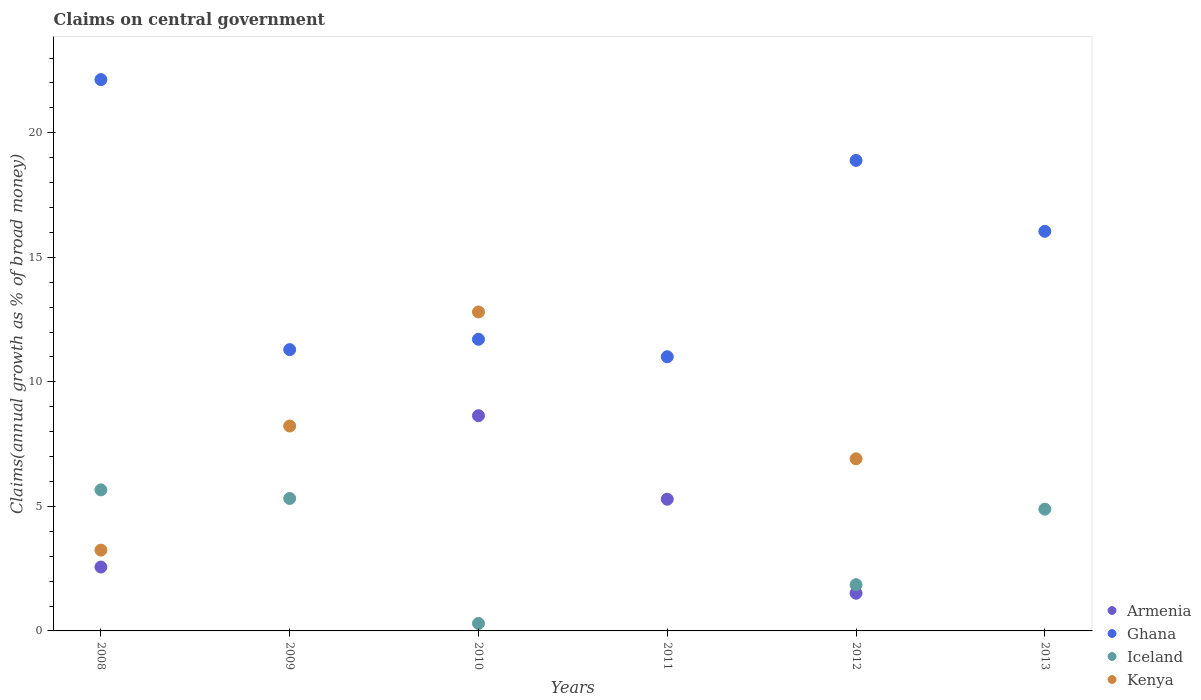Is the number of dotlines equal to the number of legend labels?
Keep it short and to the point. No. What is the percentage of broad money claimed on centeral government in Armenia in 2011?
Your answer should be compact. 5.29. Across all years, what is the maximum percentage of broad money claimed on centeral government in Armenia?
Your answer should be very brief. 8.64. What is the total percentage of broad money claimed on centeral government in Kenya in the graph?
Your response must be concise. 31.19. What is the difference between the percentage of broad money claimed on centeral government in Iceland in 2009 and that in 2013?
Offer a very short reply. 0.43. What is the difference between the percentage of broad money claimed on centeral government in Iceland in 2013 and the percentage of broad money claimed on centeral government in Ghana in 2009?
Your response must be concise. -6.41. What is the average percentage of broad money claimed on centeral government in Ghana per year?
Provide a succinct answer. 15.18. In the year 2012, what is the difference between the percentage of broad money claimed on centeral government in Ghana and percentage of broad money claimed on centeral government in Armenia?
Make the answer very short. 17.38. In how many years, is the percentage of broad money claimed on centeral government in Armenia greater than 2 %?
Provide a short and direct response. 3. What is the ratio of the percentage of broad money claimed on centeral government in Ghana in 2009 to that in 2013?
Provide a short and direct response. 0.7. Is the percentage of broad money claimed on centeral government in Ghana in 2009 less than that in 2011?
Provide a succinct answer. No. What is the difference between the highest and the second highest percentage of broad money claimed on centeral government in Ghana?
Offer a very short reply. 3.24. What is the difference between the highest and the lowest percentage of broad money claimed on centeral government in Iceland?
Your answer should be very brief. 5.66. Is the sum of the percentage of broad money claimed on centeral government in Iceland in 2008 and 2012 greater than the maximum percentage of broad money claimed on centeral government in Ghana across all years?
Provide a short and direct response. No. Is it the case that in every year, the sum of the percentage of broad money claimed on centeral government in Iceland and percentage of broad money claimed on centeral government in Kenya  is greater than the percentage of broad money claimed on centeral government in Armenia?
Ensure brevity in your answer.  No. Is the percentage of broad money claimed on centeral government in Armenia strictly greater than the percentage of broad money claimed on centeral government in Iceland over the years?
Offer a terse response. No. Are the values on the major ticks of Y-axis written in scientific E-notation?
Ensure brevity in your answer.  No. Does the graph contain grids?
Keep it short and to the point. No. How many legend labels are there?
Give a very brief answer. 4. How are the legend labels stacked?
Your answer should be compact. Vertical. What is the title of the graph?
Give a very brief answer. Claims on central government. Does "Luxembourg" appear as one of the legend labels in the graph?
Your answer should be compact. No. What is the label or title of the Y-axis?
Keep it short and to the point. Claims(annual growth as % of broad money). What is the Claims(annual growth as % of broad money) of Armenia in 2008?
Give a very brief answer. 2.57. What is the Claims(annual growth as % of broad money) in Ghana in 2008?
Keep it short and to the point. 22.13. What is the Claims(annual growth as % of broad money) of Iceland in 2008?
Offer a very short reply. 5.66. What is the Claims(annual growth as % of broad money) in Kenya in 2008?
Your answer should be compact. 3.24. What is the Claims(annual growth as % of broad money) of Ghana in 2009?
Offer a very short reply. 11.29. What is the Claims(annual growth as % of broad money) in Iceland in 2009?
Your answer should be very brief. 5.32. What is the Claims(annual growth as % of broad money) in Kenya in 2009?
Give a very brief answer. 8.23. What is the Claims(annual growth as % of broad money) in Armenia in 2010?
Your response must be concise. 8.64. What is the Claims(annual growth as % of broad money) in Ghana in 2010?
Provide a short and direct response. 11.71. What is the Claims(annual growth as % of broad money) of Iceland in 2010?
Give a very brief answer. 0.3. What is the Claims(annual growth as % of broad money) of Kenya in 2010?
Provide a succinct answer. 12.81. What is the Claims(annual growth as % of broad money) of Armenia in 2011?
Give a very brief answer. 5.29. What is the Claims(annual growth as % of broad money) in Ghana in 2011?
Provide a succinct answer. 11.01. What is the Claims(annual growth as % of broad money) of Kenya in 2011?
Your answer should be compact. 0. What is the Claims(annual growth as % of broad money) of Armenia in 2012?
Provide a succinct answer. 1.51. What is the Claims(annual growth as % of broad money) in Ghana in 2012?
Give a very brief answer. 18.89. What is the Claims(annual growth as % of broad money) of Iceland in 2012?
Give a very brief answer. 1.86. What is the Claims(annual growth as % of broad money) of Kenya in 2012?
Ensure brevity in your answer.  6.91. What is the Claims(annual growth as % of broad money) of Ghana in 2013?
Offer a very short reply. 16.04. What is the Claims(annual growth as % of broad money) in Iceland in 2013?
Ensure brevity in your answer.  4.89. What is the Claims(annual growth as % of broad money) of Kenya in 2013?
Your answer should be very brief. 0. Across all years, what is the maximum Claims(annual growth as % of broad money) of Armenia?
Offer a terse response. 8.64. Across all years, what is the maximum Claims(annual growth as % of broad money) in Ghana?
Ensure brevity in your answer.  22.13. Across all years, what is the maximum Claims(annual growth as % of broad money) of Iceland?
Give a very brief answer. 5.66. Across all years, what is the maximum Claims(annual growth as % of broad money) of Kenya?
Ensure brevity in your answer.  12.81. Across all years, what is the minimum Claims(annual growth as % of broad money) in Armenia?
Your answer should be compact. 0. Across all years, what is the minimum Claims(annual growth as % of broad money) in Ghana?
Give a very brief answer. 11.01. Across all years, what is the minimum Claims(annual growth as % of broad money) of Iceland?
Ensure brevity in your answer.  0. Across all years, what is the minimum Claims(annual growth as % of broad money) of Kenya?
Your answer should be very brief. 0. What is the total Claims(annual growth as % of broad money) in Armenia in the graph?
Provide a succinct answer. 18.01. What is the total Claims(annual growth as % of broad money) in Ghana in the graph?
Provide a succinct answer. 91.08. What is the total Claims(annual growth as % of broad money) of Iceland in the graph?
Your answer should be very brief. 18.03. What is the total Claims(annual growth as % of broad money) in Kenya in the graph?
Ensure brevity in your answer.  31.19. What is the difference between the Claims(annual growth as % of broad money) of Ghana in 2008 and that in 2009?
Make the answer very short. 10.84. What is the difference between the Claims(annual growth as % of broad money) of Iceland in 2008 and that in 2009?
Give a very brief answer. 0.35. What is the difference between the Claims(annual growth as % of broad money) of Kenya in 2008 and that in 2009?
Offer a very short reply. -4.98. What is the difference between the Claims(annual growth as % of broad money) of Armenia in 2008 and that in 2010?
Your answer should be compact. -6.08. What is the difference between the Claims(annual growth as % of broad money) of Ghana in 2008 and that in 2010?
Your response must be concise. 10.43. What is the difference between the Claims(annual growth as % of broad money) in Iceland in 2008 and that in 2010?
Give a very brief answer. 5.36. What is the difference between the Claims(annual growth as % of broad money) of Kenya in 2008 and that in 2010?
Make the answer very short. -9.56. What is the difference between the Claims(annual growth as % of broad money) in Armenia in 2008 and that in 2011?
Offer a terse response. -2.72. What is the difference between the Claims(annual growth as % of broad money) of Ghana in 2008 and that in 2011?
Your answer should be very brief. 11.13. What is the difference between the Claims(annual growth as % of broad money) of Armenia in 2008 and that in 2012?
Offer a terse response. 1.05. What is the difference between the Claims(annual growth as % of broad money) in Ghana in 2008 and that in 2012?
Give a very brief answer. 3.24. What is the difference between the Claims(annual growth as % of broad money) in Iceland in 2008 and that in 2012?
Your answer should be very brief. 3.81. What is the difference between the Claims(annual growth as % of broad money) of Kenya in 2008 and that in 2012?
Provide a succinct answer. -3.67. What is the difference between the Claims(annual growth as % of broad money) of Ghana in 2008 and that in 2013?
Give a very brief answer. 6.09. What is the difference between the Claims(annual growth as % of broad money) in Iceland in 2008 and that in 2013?
Keep it short and to the point. 0.77. What is the difference between the Claims(annual growth as % of broad money) in Ghana in 2009 and that in 2010?
Give a very brief answer. -0.41. What is the difference between the Claims(annual growth as % of broad money) in Iceland in 2009 and that in 2010?
Provide a short and direct response. 5.02. What is the difference between the Claims(annual growth as % of broad money) in Kenya in 2009 and that in 2010?
Ensure brevity in your answer.  -4.58. What is the difference between the Claims(annual growth as % of broad money) of Ghana in 2009 and that in 2011?
Provide a short and direct response. 0.29. What is the difference between the Claims(annual growth as % of broad money) of Ghana in 2009 and that in 2012?
Give a very brief answer. -7.6. What is the difference between the Claims(annual growth as % of broad money) in Iceland in 2009 and that in 2012?
Offer a terse response. 3.46. What is the difference between the Claims(annual growth as % of broad money) in Kenya in 2009 and that in 2012?
Offer a terse response. 1.32. What is the difference between the Claims(annual growth as % of broad money) in Ghana in 2009 and that in 2013?
Offer a very short reply. -4.75. What is the difference between the Claims(annual growth as % of broad money) in Iceland in 2009 and that in 2013?
Your answer should be very brief. 0.43. What is the difference between the Claims(annual growth as % of broad money) in Armenia in 2010 and that in 2011?
Give a very brief answer. 3.35. What is the difference between the Claims(annual growth as % of broad money) of Ghana in 2010 and that in 2011?
Provide a succinct answer. 0.7. What is the difference between the Claims(annual growth as % of broad money) in Armenia in 2010 and that in 2012?
Give a very brief answer. 7.13. What is the difference between the Claims(annual growth as % of broad money) of Ghana in 2010 and that in 2012?
Provide a short and direct response. -7.18. What is the difference between the Claims(annual growth as % of broad money) in Iceland in 2010 and that in 2012?
Give a very brief answer. -1.56. What is the difference between the Claims(annual growth as % of broad money) of Kenya in 2010 and that in 2012?
Keep it short and to the point. 5.9. What is the difference between the Claims(annual growth as % of broad money) in Ghana in 2010 and that in 2013?
Your answer should be compact. -4.33. What is the difference between the Claims(annual growth as % of broad money) in Iceland in 2010 and that in 2013?
Your answer should be compact. -4.59. What is the difference between the Claims(annual growth as % of broad money) of Armenia in 2011 and that in 2012?
Your answer should be very brief. 3.78. What is the difference between the Claims(annual growth as % of broad money) in Ghana in 2011 and that in 2012?
Your answer should be very brief. -7.88. What is the difference between the Claims(annual growth as % of broad money) in Ghana in 2011 and that in 2013?
Make the answer very short. -5.03. What is the difference between the Claims(annual growth as % of broad money) in Ghana in 2012 and that in 2013?
Offer a terse response. 2.85. What is the difference between the Claims(annual growth as % of broad money) of Iceland in 2012 and that in 2013?
Give a very brief answer. -3.03. What is the difference between the Claims(annual growth as % of broad money) of Armenia in 2008 and the Claims(annual growth as % of broad money) of Ghana in 2009?
Your answer should be very brief. -8.73. What is the difference between the Claims(annual growth as % of broad money) of Armenia in 2008 and the Claims(annual growth as % of broad money) of Iceland in 2009?
Ensure brevity in your answer.  -2.75. What is the difference between the Claims(annual growth as % of broad money) of Armenia in 2008 and the Claims(annual growth as % of broad money) of Kenya in 2009?
Give a very brief answer. -5.66. What is the difference between the Claims(annual growth as % of broad money) in Ghana in 2008 and the Claims(annual growth as % of broad money) in Iceland in 2009?
Offer a very short reply. 16.82. What is the difference between the Claims(annual growth as % of broad money) in Ghana in 2008 and the Claims(annual growth as % of broad money) in Kenya in 2009?
Keep it short and to the point. 13.91. What is the difference between the Claims(annual growth as % of broad money) of Iceland in 2008 and the Claims(annual growth as % of broad money) of Kenya in 2009?
Ensure brevity in your answer.  -2.56. What is the difference between the Claims(annual growth as % of broad money) of Armenia in 2008 and the Claims(annual growth as % of broad money) of Ghana in 2010?
Ensure brevity in your answer.  -9.14. What is the difference between the Claims(annual growth as % of broad money) in Armenia in 2008 and the Claims(annual growth as % of broad money) in Iceland in 2010?
Offer a terse response. 2.26. What is the difference between the Claims(annual growth as % of broad money) of Armenia in 2008 and the Claims(annual growth as % of broad money) of Kenya in 2010?
Your answer should be compact. -10.24. What is the difference between the Claims(annual growth as % of broad money) in Ghana in 2008 and the Claims(annual growth as % of broad money) in Iceland in 2010?
Ensure brevity in your answer.  21.83. What is the difference between the Claims(annual growth as % of broad money) of Ghana in 2008 and the Claims(annual growth as % of broad money) of Kenya in 2010?
Offer a terse response. 9.33. What is the difference between the Claims(annual growth as % of broad money) in Iceland in 2008 and the Claims(annual growth as % of broad money) in Kenya in 2010?
Your response must be concise. -7.14. What is the difference between the Claims(annual growth as % of broad money) of Armenia in 2008 and the Claims(annual growth as % of broad money) of Ghana in 2011?
Provide a succinct answer. -8.44. What is the difference between the Claims(annual growth as % of broad money) of Armenia in 2008 and the Claims(annual growth as % of broad money) of Ghana in 2012?
Make the answer very short. -16.32. What is the difference between the Claims(annual growth as % of broad money) of Armenia in 2008 and the Claims(annual growth as % of broad money) of Iceland in 2012?
Offer a very short reply. 0.71. What is the difference between the Claims(annual growth as % of broad money) of Armenia in 2008 and the Claims(annual growth as % of broad money) of Kenya in 2012?
Give a very brief answer. -4.35. What is the difference between the Claims(annual growth as % of broad money) of Ghana in 2008 and the Claims(annual growth as % of broad money) of Iceland in 2012?
Your answer should be very brief. 20.28. What is the difference between the Claims(annual growth as % of broad money) in Ghana in 2008 and the Claims(annual growth as % of broad money) in Kenya in 2012?
Keep it short and to the point. 15.22. What is the difference between the Claims(annual growth as % of broad money) in Iceland in 2008 and the Claims(annual growth as % of broad money) in Kenya in 2012?
Give a very brief answer. -1.25. What is the difference between the Claims(annual growth as % of broad money) of Armenia in 2008 and the Claims(annual growth as % of broad money) of Ghana in 2013?
Your answer should be compact. -13.48. What is the difference between the Claims(annual growth as % of broad money) in Armenia in 2008 and the Claims(annual growth as % of broad money) in Iceland in 2013?
Ensure brevity in your answer.  -2.32. What is the difference between the Claims(annual growth as % of broad money) of Ghana in 2008 and the Claims(annual growth as % of broad money) of Iceland in 2013?
Give a very brief answer. 17.25. What is the difference between the Claims(annual growth as % of broad money) in Ghana in 2009 and the Claims(annual growth as % of broad money) in Iceland in 2010?
Ensure brevity in your answer.  10.99. What is the difference between the Claims(annual growth as % of broad money) of Ghana in 2009 and the Claims(annual growth as % of broad money) of Kenya in 2010?
Keep it short and to the point. -1.51. What is the difference between the Claims(annual growth as % of broad money) of Iceland in 2009 and the Claims(annual growth as % of broad money) of Kenya in 2010?
Offer a very short reply. -7.49. What is the difference between the Claims(annual growth as % of broad money) of Ghana in 2009 and the Claims(annual growth as % of broad money) of Iceland in 2012?
Give a very brief answer. 9.44. What is the difference between the Claims(annual growth as % of broad money) in Ghana in 2009 and the Claims(annual growth as % of broad money) in Kenya in 2012?
Your response must be concise. 4.38. What is the difference between the Claims(annual growth as % of broad money) of Iceland in 2009 and the Claims(annual growth as % of broad money) of Kenya in 2012?
Your answer should be compact. -1.59. What is the difference between the Claims(annual growth as % of broad money) of Ghana in 2009 and the Claims(annual growth as % of broad money) of Iceland in 2013?
Your response must be concise. 6.41. What is the difference between the Claims(annual growth as % of broad money) of Armenia in 2010 and the Claims(annual growth as % of broad money) of Ghana in 2011?
Provide a succinct answer. -2.37. What is the difference between the Claims(annual growth as % of broad money) of Armenia in 2010 and the Claims(annual growth as % of broad money) of Ghana in 2012?
Provide a succinct answer. -10.25. What is the difference between the Claims(annual growth as % of broad money) of Armenia in 2010 and the Claims(annual growth as % of broad money) of Iceland in 2012?
Provide a succinct answer. 6.79. What is the difference between the Claims(annual growth as % of broad money) of Armenia in 2010 and the Claims(annual growth as % of broad money) of Kenya in 2012?
Provide a succinct answer. 1.73. What is the difference between the Claims(annual growth as % of broad money) in Ghana in 2010 and the Claims(annual growth as % of broad money) in Iceland in 2012?
Your answer should be very brief. 9.85. What is the difference between the Claims(annual growth as % of broad money) of Ghana in 2010 and the Claims(annual growth as % of broad money) of Kenya in 2012?
Make the answer very short. 4.8. What is the difference between the Claims(annual growth as % of broad money) in Iceland in 2010 and the Claims(annual growth as % of broad money) in Kenya in 2012?
Provide a short and direct response. -6.61. What is the difference between the Claims(annual growth as % of broad money) of Armenia in 2010 and the Claims(annual growth as % of broad money) of Ghana in 2013?
Offer a very short reply. -7.4. What is the difference between the Claims(annual growth as % of broad money) of Armenia in 2010 and the Claims(annual growth as % of broad money) of Iceland in 2013?
Ensure brevity in your answer.  3.75. What is the difference between the Claims(annual growth as % of broad money) in Ghana in 2010 and the Claims(annual growth as % of broad money) in Iceland in 2013?
Give a very brief answer. 6.82. What is the difference between the Claims(annual growth as % of broad money) in Armenia in 2011 and the Claims(annual growth as % of broad money) in Ghana in 2012?
Provide a succinct answer. -13.6. What is the difference between the Claims(annual growth as % of broad money) of Armenia in 2011 and the Claims(annual growth as % of broad money) of Iceland in 2012?
Your answer should be compact. 3.43. What is the difference between the Claims(annual growth as % of broad money) of Armenia in 2011 and the Claims(annual growth as % of broad money) of Kenya in 2012?
Your response must be concise. -1.62. What is the difference between the Claims(annual growth as % of broad money) of Ghana in 2011 and the Claims(annual growth as % of broad money) of Iceland in 2012?
Ensure brevity in your answer.  9.15. What is the difference between the Claims(annual growth as % of broad money) in Ghana in 2011 and the Claims(annual growth as % of broad money) in Kenya in 2012?
Your answer should be compact. 4.1. What is the difference between the Claims(annual growth as % of broad money) of Armenia in 2011 and the Claims(annual growth as % of broad money) of Ghana in 2013?
Provide a succinct answer. -10.76. What is the difference between the Claims(annual growth as % of broad money) in Armenia in 2011 and the Claims(annual growth as % of broad money) in Iceland in 2013?
Give a very brief answer. 0.4. What is the difference between the Claims(annual growth as % of broad money) in Ghana in 2011 and the Claims(annual growth as % of broad money) in Iceland in 2013?
Give a very brief answer. 6.12. What is the difference between the Claims(annual growth as % of broad money) in Armenia in 2012 and the Claims(annual growth as % of broad money) in Ghana in 2013?
Your response must be concise. -14.53. What is the difference between the Claims(annual growth as % of broad money) in Armenia in 2012 and the Claims(annual growth as % of broad money) in Iceland in 2013?
Provide a short and direct response. -3.38. What is the difference between the Claims(annual growth as % of broad money) of Ghana in 2012 and the Claims(annual growth as % of broad money) of Iceland in 2013?
Give a very brief answer. 14. What is the average Claims(annual growth as % of broad money) of Armenia per year?
Your response must be concise. 3. What is the average Claims(annual growth as % of broad money) in Ghana per year?
Keep it short and to the point. 15.18. What is the average Claims(annual growth as % of broad money) of Iceland per year?
Provide a succinct answer. 3. What is the average Claims(annual growth as % of broad money) of Kenya per year?
Your answer should be very brief. 5.2. In the year 2008, what is the difference between the Claims(annual growth as % of broad money) of Armenia and Claims(annual growth as % of broad money) of Ghana?
Offer a very short reply. -19.57. In the year 2008, what is the difference between the Claims(annual growth as % of broad money) in Armenia and Claims(annual growth as % of broad money) in Iceland?
Provide a succinct answer. -3.1. In the year 2008, what is the difference between the Claims(annual growth as % of broad money) of Armenia and Claims(annual growth as % of broad money) of Kenya?
Your response must be concise. -0.68. In the year 2008, what is the difference between the Claims(annual growth as % of broad money) in Ghana and Claims(annual growth as % of broad money) in Iceland?
Your response must be concise. 16.47. In the year 2008, what is the difference between the Claims(annual growth as % of broad money) of Ghana and Claims(annual growth as % of broad money) of Kenya?
Offer a terse response. 18.89. In the year 2008, what is the difference between the Claims(annual growth as % of broad money) of Iceland and Claims(annual growth as % of broad money) of Kenya?
Your response must be concise. 2.42. In the year 2009, what is the difference between the Claims(annual growth as % of broad money) of Ghana and Claims(annual growth as % of broad money) of Iceland?
Make the answer very short. 5.98. In the year 2009, what is the difference between the Claims(annual growth as % of broad money) in Ghana and Claims(annual growth as % of broad money) in Kenya?
Your answer should be compact. 3.07. In the year 2009, what is the difference between the Claims(annual growth as % of broad money) of Iceland and Claims(annual growth as % of broad money) of Kenya?
Your answer should be compact. -2.91. In the year 2010, what is the difference between the Claims(annual growth as % of broad money) in Armenia and Claims(annual growth as % of broad money) in Ghana?
Your answer should be very brief. -3.07. In the year 2010, what is the difference between the Claims(annual growth as % of broad money) in Armenia and Claims(annual growth as % of broad money) in Iceland?
Keep it short and to the point. 8.34. In the year 2010, what is the difference between the Claims(annual growth as % of broad money) of Armenia and Claims(annual growth as % of broad money) of Kenya?
Offer a terse response. -4.16. In the year 2010, what is the difference between the Claims(annual growth as % of broad money) of Ghana and Claims(annual growth as % of broad money) of Iceland?
Ensure brevity in your answer.  11.41. In the year 2010, what is the difference between the Claims(annual growth as % of broad money) of Ghana and Claims(annual growth as % of broad money) of Kenya?
Ensure brevity in your answer.  -1.1. In the year 2010, what is the difference between the Claims(annual growth as % of broad money) in Iceland and Claims(annual growth as % of broad money) in Kenya?
Make the answer very short. -12.51. In the year 2011, what is the difference between the Claims(annual growth as % of broad money) in Armenia and Claims(annual growth as % of broad money) in Ghana?
Give a very brief answer. -5.72. In the year 2012, what is the difference between the Claims(annual growth as % of broad money) of Armenia and Claims(annual growth as % of broad money) of Ghana?
Provide a succinct answer. -17.38. In the year 2012, what is the difference between the Claims(annual growth as % of broad money) of Armenia and Claims(annual growth as % of broad money) of Iceland?
Keep it short and to the point. -0.34. In the year 2012, what is the difference between the Claims(annual growth as % of broad money) of Armenia and Claims(annual growth as % of broad money) of Kenya?
Your answer should be compact. -5.4. In the year 2012, what is the difference between the Claims(annual growth as % of broad money) of Ghana and Claims(annual growth as % of broad money) of Iceland?
Ensure brevity in your answer.  17.03. In the year 2012, what is the difference between the Claims(annual growth as % of broad money) in Ghana and Claims(annual growth as % of broad money) in Kenya?
Provide a succinct answer. 11.98. In the year 2012, what is the difference between the Claims(annual growth as % of broad money) in Iceland and Claims(annual growth as % of broad money) in Kenya?
Your answer should be very brief. -5.05. In the year 2013, what is the difference between the Claims(annual growth as % of broad money) in Ghana and Claims(annual growth as % of broad money) in Iceland?
Offer a terse response. 11.16. What is the ratio of the Claims(annual growth as % of broad money) of Ghana in 2008 to that in 2009?
Ensure brevity in your answer.  1.96. What is the ratio of the Claims(annual growth as % of broad money) of Iceland in 2008 to that in 2009?
Offer a very short reply. 1.06. What is the ratio of the Claims(annual growth as % of broad money) of Kenya in 2008 to that in 2009?
Keep it short and to the point. 0.39. What is the ratio of the Claims(annual growth as % of broad money) in Armenia in 2008 to that in 2010?
Provide a succinct answer. 0.3. What is the ratio of the Claims(annual growth as % of broad money) of Ghana in 2008 to that in 2010?
Keep it short and to the point. 1.89. What is the ratio of the Claims(annual growth as % of broad money) of Iceland in 2008 to that in 2010?
Your answer should be compact. 18.84. What is the ratio of the Claims(annual growth as % of broad money) of Kenya in 2008 to that in 2010?
Ensure brevity in your answer.  0.25. What is the ratio of the Claims(annual growth as % of broad money) in Armenia in 2008 to that in 2011?
Provide a short and direct response. 0.49. What is the ratio of the Claims(annual growth as % of broad money) of Ghana in 2008 to that in 2011?
Your response must be concise. 2.01. What is the ratio of the Claims(annual growth as % of broad money) in Armenia in 2008 to that in 2012?
Ensure brevity in your answer.  1.7. What is the ratio of the Claims(annual growth as % of broad money) in Ghana in 2008 to that in 2012?
Provide a succinct answer. 1.17. What is the ratio of the Claims(annual growth as % of broad money) of Iceland in 2008 to that in 2012?
Your answer should be very brief. 3.05. What is the ratio of the Claims(annual growth as % of broad money) in Kenya in 2008 to that in 2012?
Your response must be concise. 0.47. What is the ratio of the Claims(annual growth as % of broad money) in Ghana in 2008 to that in 2013?
Provide a succinct answer. 1.38. What is the ratio of the Claims(annual growth as % of broad money) of Iceland in 2008 to that in 2013?
Ensure brevity in your answer.  1.16. What is the ratio of the Claims(annual growth as % of broad money) of Ghana in 2009 to that in 2010?
Give a very brief answer. 0.96. What is the ratio of the Claims(annual growth as % of broad money) of Iceland in 2009 to that in 2010?
Provide a succinct answer. 17.69. What is the ratio of the Claims(annual growth as % of broad money) of Kenya in 2009 to that in 2010?
Ensure brevity in your answer.  0.64. What is the ratio of the Claims(annual growth as % of broad money) of Ghana in 2009 to that in 2012?
Provide a succinct answer. 0.6. What is the ratio of the Claims(annual growth as % of broad money) in Iceland in 2009 to that in 2012?
Ensure brevity in your answer.  2.86. What is the ratio of the Claims(annual growth as % of broad money) of Kenya in 2009 to that in 2012?
Provide a short and direct response. 1.19. What is the ratio of the Claims(annual growth as % of broad money) in Ghana in 2009 to that in 2013?
Keep it short and to the point. 0.7. What is the ratio of the Claims(annual growth as % of broad money) of Iceland in 2009 to that in 2013?
Give a very brief answer. 1.09. What is the ratio of the Claims(annual growth as % of broad money) of Armenia in 2010 to that in 2011?
Provide a short and direct response. 1.63. What is the ratio of the Claims(annual growth as % of broad money) in Ghana in 2010 to that in 2011?
Provide a succinct answer. 1.06. What is the ratio of the Claims(annual growth as % of broad money) of Armenia in 2010 to that in 2012?
Your response must be concise. 5.71. What is the ratio of the Claims(annual growth as % of broad money) of Ghana in 2010 to that in 2012?
Your response must be concise. 0.62. What is the ratio of the Claims(annual growth as % of broad money) of Iceland in 2010 to that in 2012?
Your answer should be very brief. 0.16. What is the ratio of the Claims(annual growth as % of broad money) of Kenya in 2010 to that in 2012?
Your response must be concise. 1.85. What is the ratio of the Claims(annual growth as % of broad money) in Ghana in 2010 to that in 2013?
Provide a succinct answer. 0.73. What is the ratio of the Claims(annual growth as % of broad money) in Iceland in 2010 to that in 2013?
Offer a terse response. 0.06. What is the ratio of the Claims(annual growth as % of broad money) of Armenia in 2011 to that in 2012?
Your answer should be very brief. 3.5. What is the ratio of the Claims(annual growth as % of broad money) in Ghana in 2011 to that in 2012?
Offer a terse response. 0.58. What is the ratio of the Claims(annual growth as % of broad money) of Ghana in 2011 to that in 2013?
Ensure brevity in your answer.  0.69. What is the ratio of the Claims(annual growth as % of broad money) in Ghana in 2012 to that in 2013?
Give a very brief answer. 1.18. What is the ratio of the Claims(annual growth as % of broad money) in Iceland in 2012 to that in 2013?
Your answer should be compact. 0.38. What is the difference between the highest and the second highest Claims(annual growth as % of broad money) of Armenia?
Offer a terse response. 3.35. What is the difference between the highest and the second highest Claims(annual growth as % of broad money) of Ghana?
Keep it short and to the point. 3.24. What is the difference between the highest and the second highest Claims(annual growth as % of broad money) of Iceland?
Make the answer very short. 0.35. What is the difference between the highest and the second highest Claims(annual growth as % of broad money) of Kenya?
Offer a very short reply. 4.58. What is the difference between the highest and the lowest Claims(annual growth as % of broad money) of Armenia?
Provide a short and direct response. 8.64. What is the difference between the highest and the lowest Claims(annual growth as % of broad money) in Ghana?
Provide a short and direct response. 11.13. What is the difference between the highest and the lowest Claims(annual growth as % of broad money) of Iceland?
Provide a short and direct response. 5.66. What is the difference between the highest and the lowest Claims(annual growth as % of broad money) in Kenya?
Make the answer very short. 12.81. 